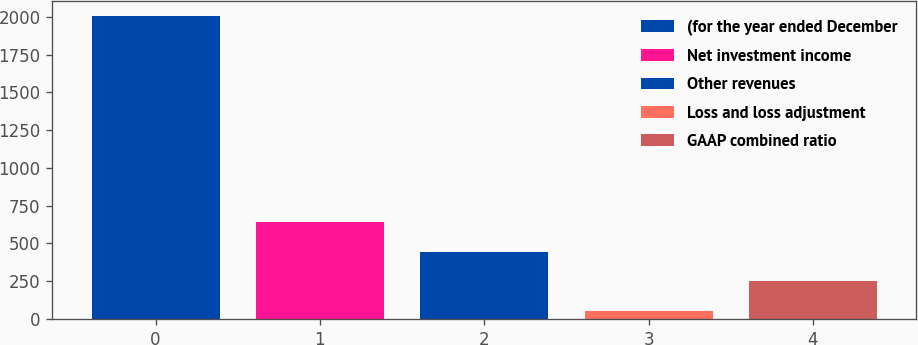<chart> <loc_0><loc_0><loc_500><loc_500><bar_chart><fcel>(for the year ended December<fcel>Net investment income<fcel>Other revenues<fcel>Loss and loss adjustment<fcel>GAAP combined ratio<nl><fcel>2006<fcel>640.16<fcel>445.04<fcel>54.8<fcel>249.92<nl></chart> 